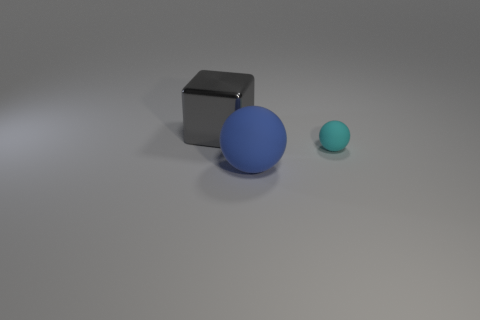How many blocks are either tiny cyan matte things or small gray metal objects? There is one small gray metal cube and one tiny cyan matte sphere in the image, making a total of two objects that fit the criteria. 